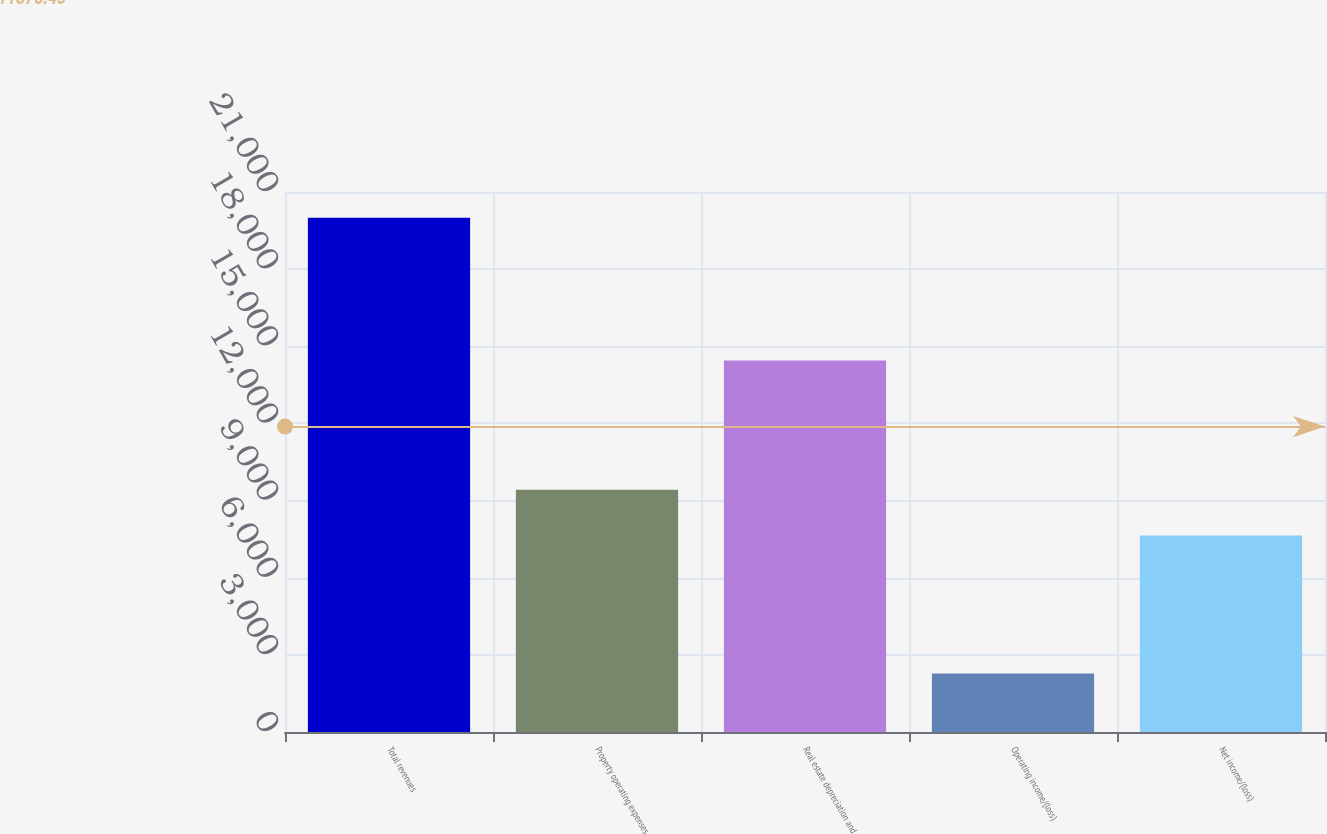<chart> <loc_0><loc_0><loc_500><loc_500><bar_chart><fcel>Total revenues<fcel>Property operating expenses<fcel>Real estate depreciation and<fcel>Operating income/(loss)<fcel>Net income/(loss)<nl><fcel>19997<fcel>9416.2<fcel>14444<fcel>2275<fcel>7644<nl></chart> 